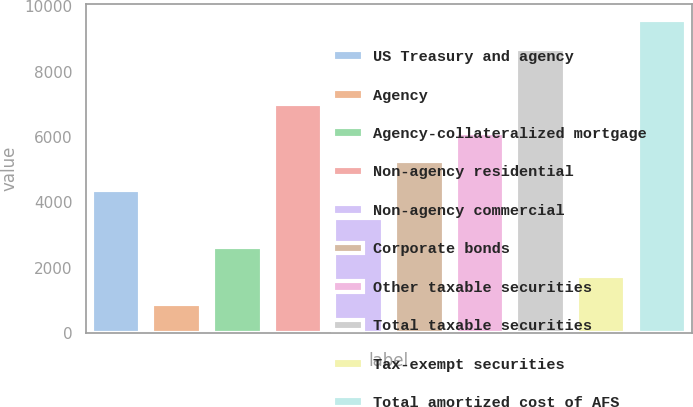Convert chart to OTSL. <chart><loc_0><loc_0><loc_500><loc_500><bar_chart><fcel>US Treasury and agency<fcel>Agency<fcel>Agency-collateralized mortgage<fcel>Non-agency residential<fcel>Non-agency commercial<fcel>Corporate bonds<fcel>Other taxable securities<fcel>Total taxable securities<fcel>Tax-exempt securities<fcel>Total amortized cost of AFS<nl><fcel>4385<fcel>884.2<fcel>2634.6<fcel>7010.6<fcel>3509.8<fcel>5260.2<fcel>6135.4<fcel>8707<fcel>1759.4<fcel>9582.2<nl></chart> 